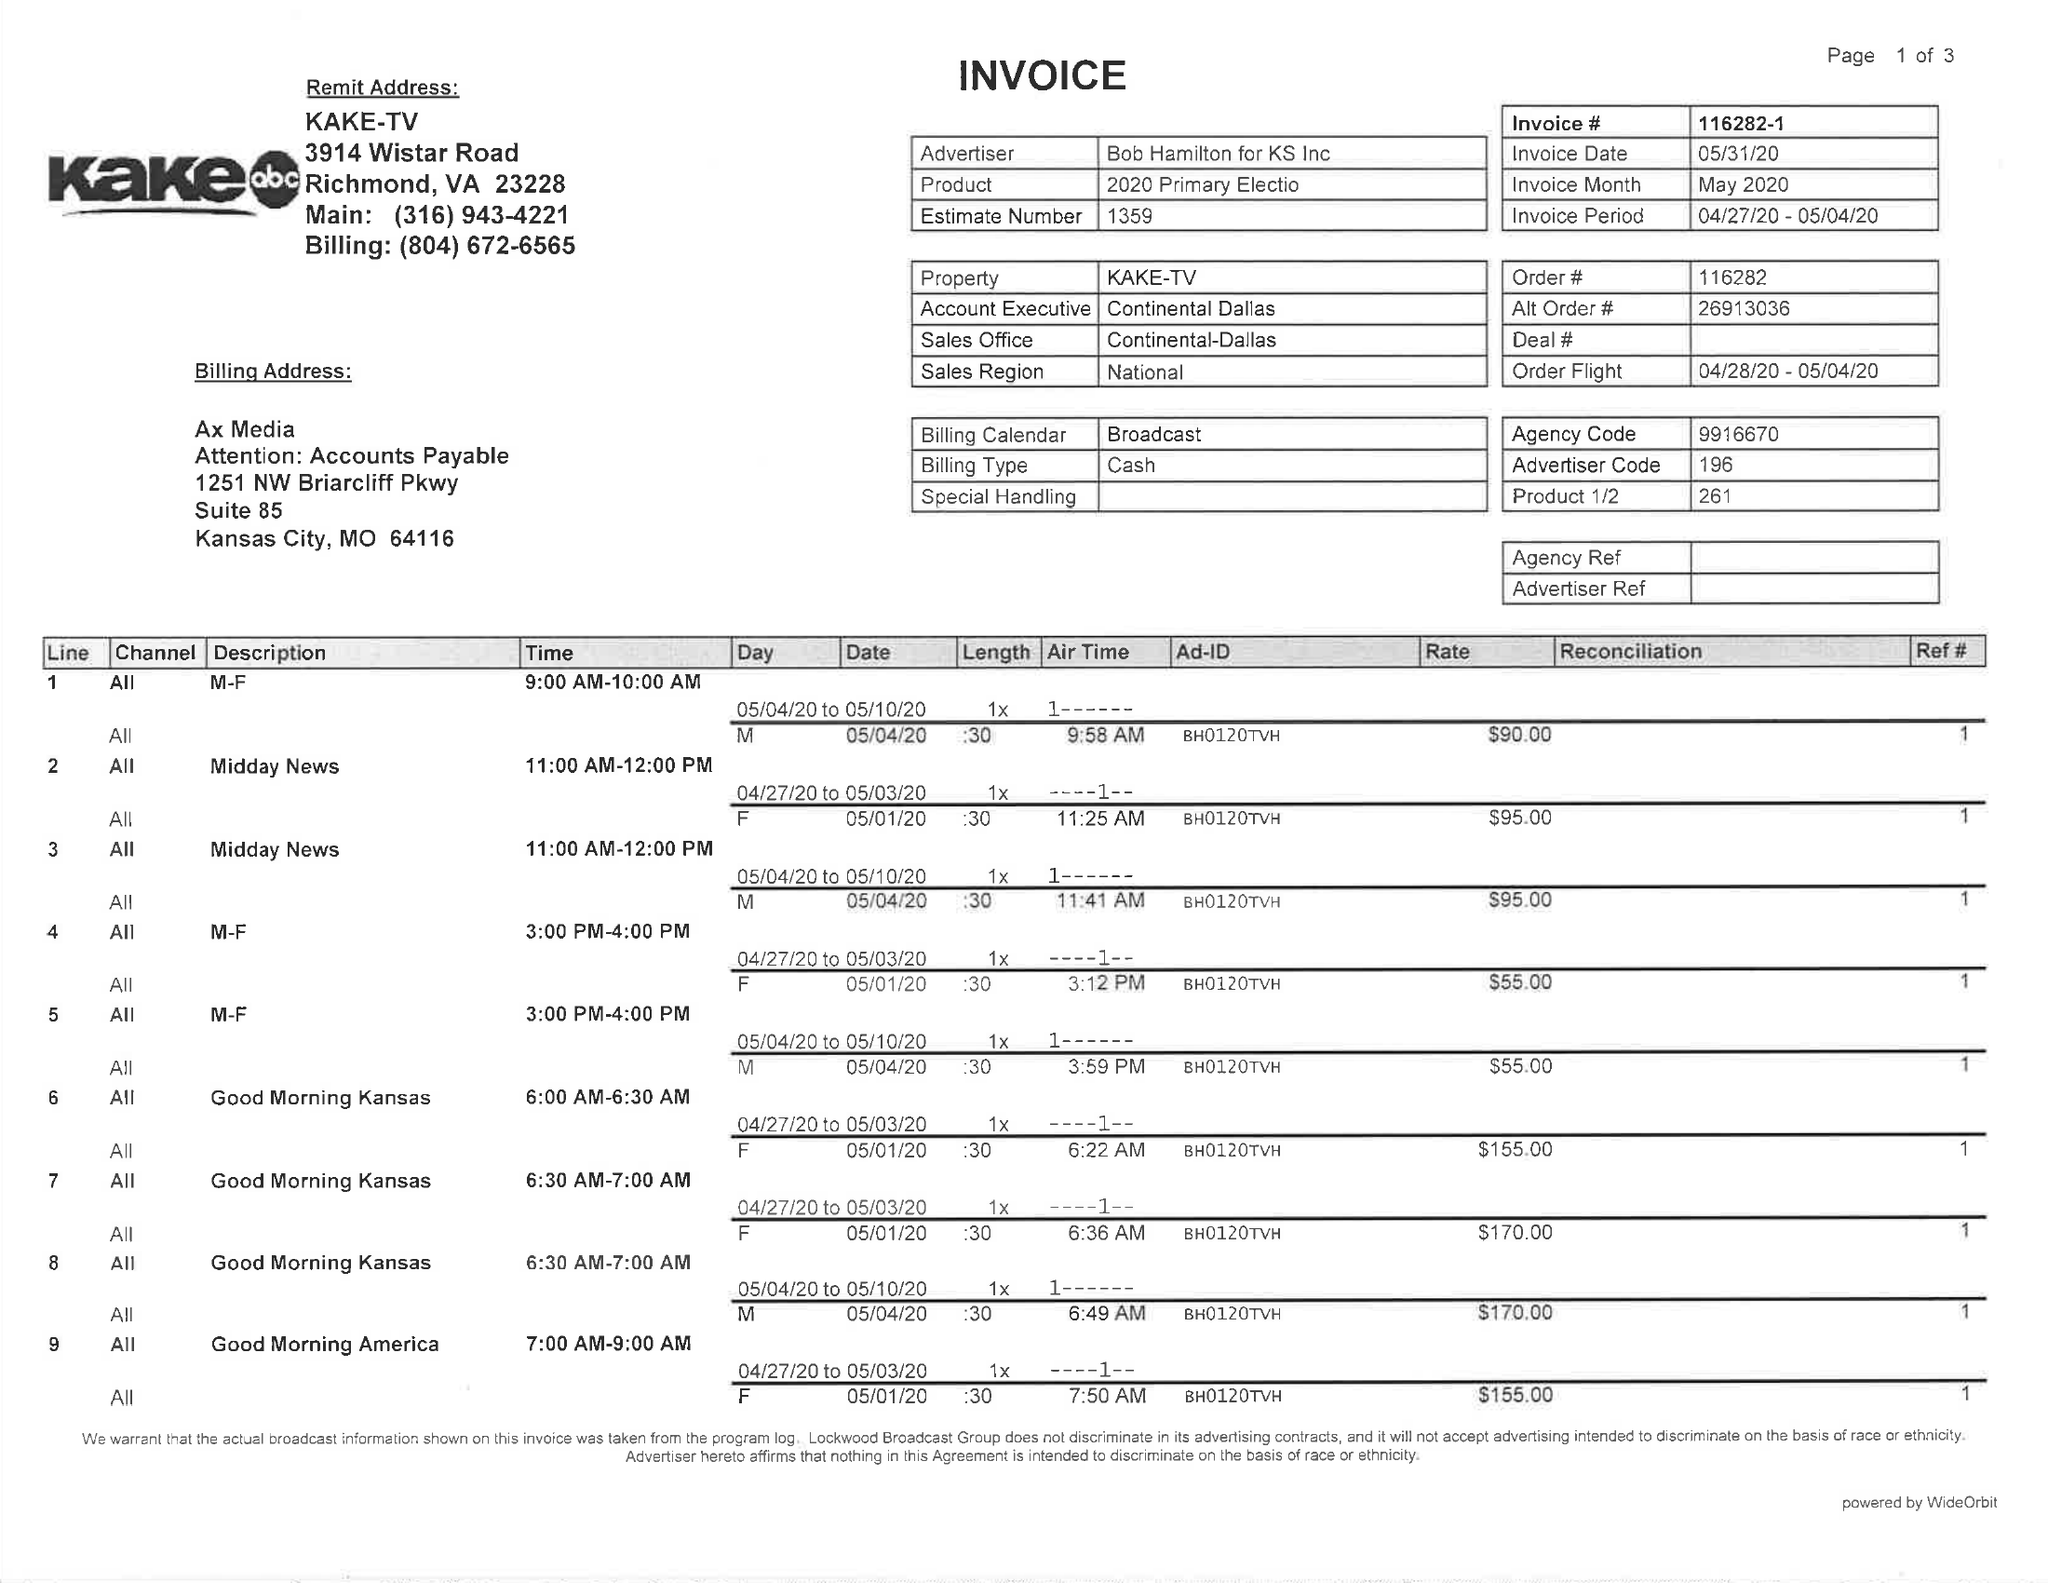What is the value for the flight_to?
Answer the question using a single word or phrase. 05/04/20 